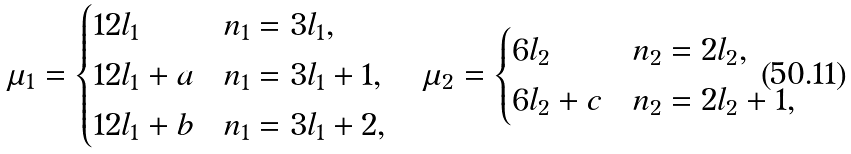<formula> <loc_0><loc_0><loc_500><loc_500>\mu _ { 1 } = \begin{cases} 1 2 l _ { 1 } & n _ { 1 } = 3 l _ { 1 } , \\ 1 2 l _ { 1 } + a & n _ { 1 } = 3 l _ { 1 } + 1 , \\ 1 2 l _ { 1 } + b & n _ { 1 } = 3 l _ { 1 } + 2 , \end{cases} \quad \mu _ { 2 } = \begin{cases} 6 l _ { 2 } & n _ { 2 } = 2 l _ { 2 } , \\ 6 l _ { 2 } + c & n _ { 2 } = 2 l _ { 2 } + 1 , \end{cases}</formula> 